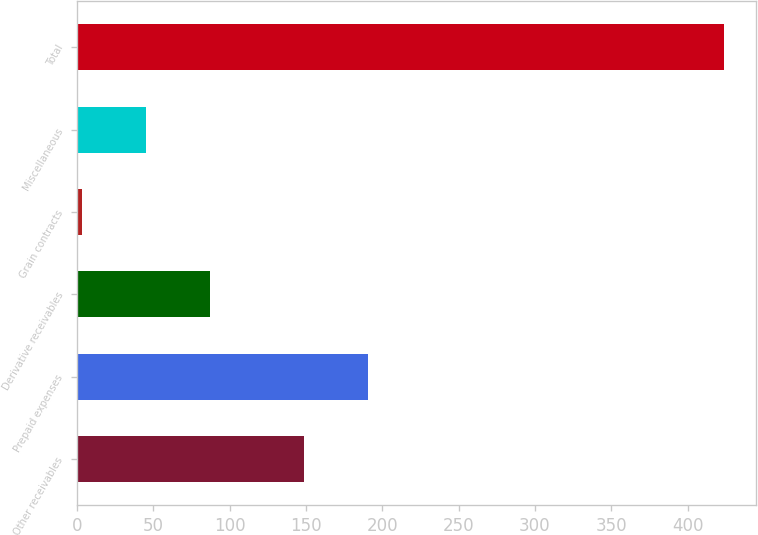<chart> <loc_0><loc_0><loc_500><loc_500><bar_chart><fcel>Other receivables<fcel>Prepaid expenses<fcel>Derivative receivables<fcel>Grain contracts<fcel>Miscellaneous<fcel>Total<nl><fcel>148.8<fcel>190.85<fcel>87.4<fcel>3.3<fcel>45.35<fcel>423.8<nl></chart> 